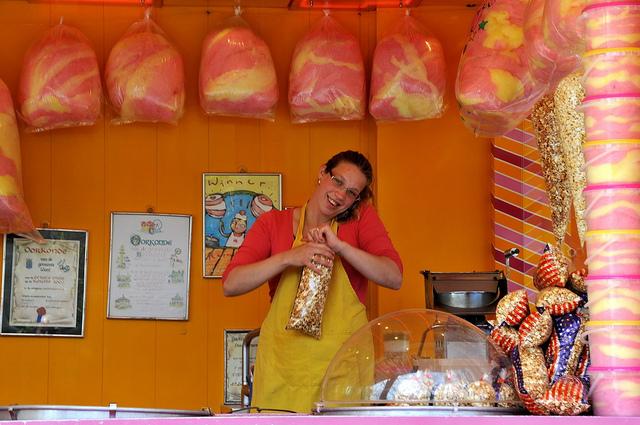Who is wearing glasses?
Give a very brief answer. Woman. What colors are the cotton candy?
Keep it brief. Pink and yellow. What are hanging on the wall?
Quick response, please. Cotton candy. What is this a collection of?
Write a very short answer. Cotton candy. 